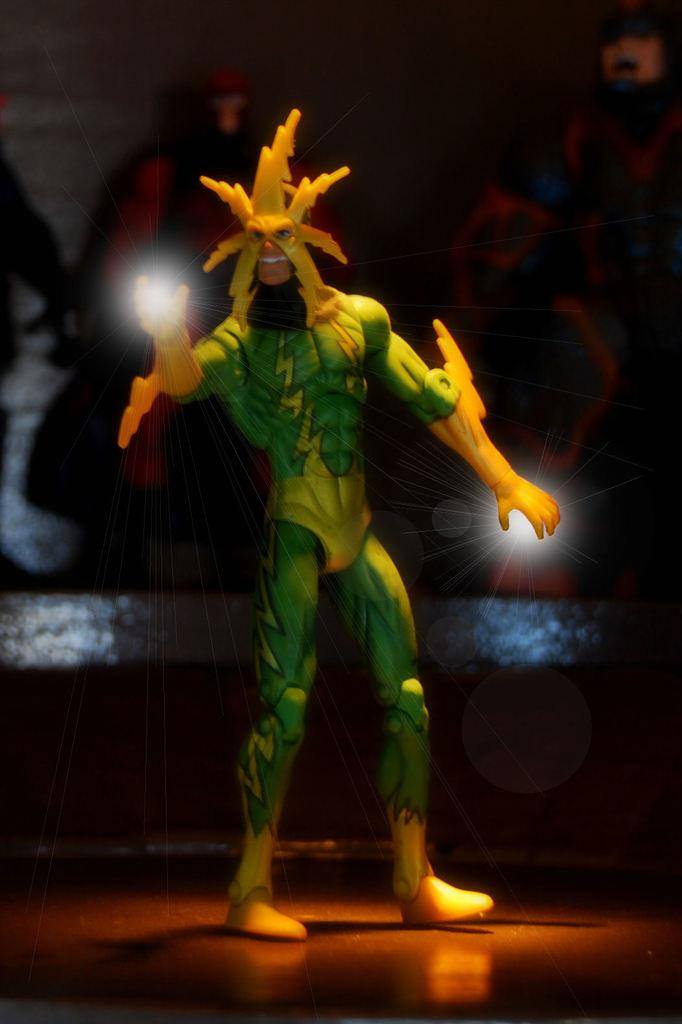What object can be seen in the image? There is a toy in the image. Where is the toy located? The toy is standing on the floor. What is the toy holding in its hand? The toy has a light in its hand. What can be seen in the background of the image? There is a wall in the background of the image. What type of decorations are on the wall? There are posters of superheroes on the on the wall. What type of soup is being served in the image? There is no soup present in the image; it features a toy standing on the floor with a light in its hand and posters of superheroes on the wall. 